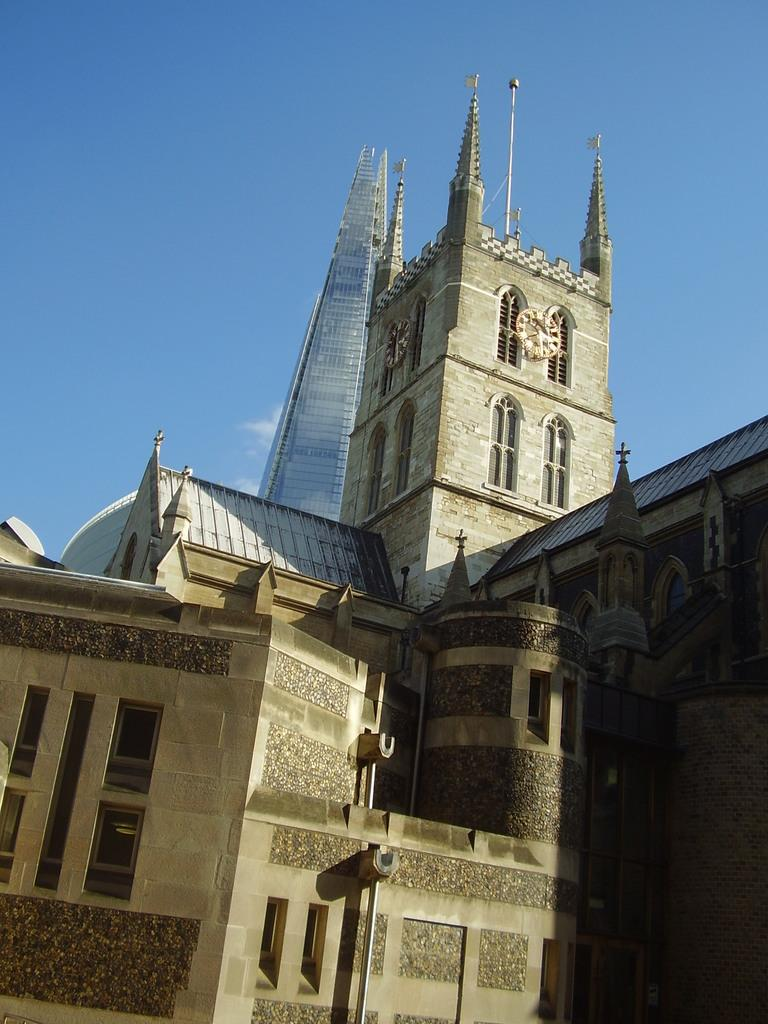What structures are present in the image? There are buildings in the image. What part of the natural environment is visible in the image? The sky is visible in the background of the image. What type of pain is being experienced by the buildings in the image? There is no indication of pain in the image, as buildings are inanimate objects and cannot experience pain. 